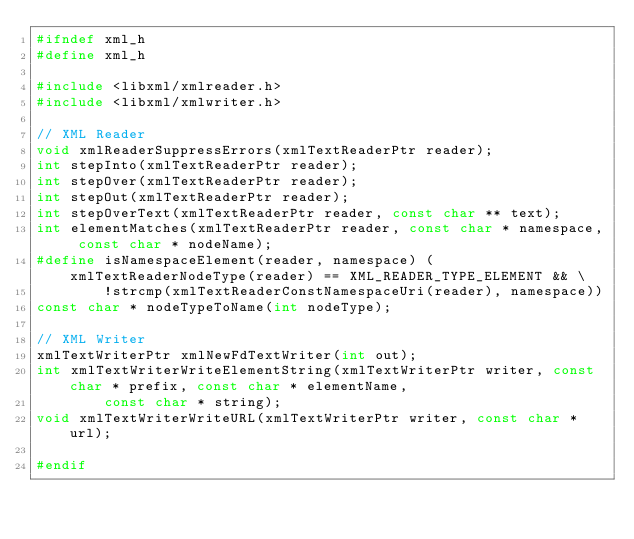<code> <loc_0><loc_0><loc_500><loc_500><_C_>#ifndef xml_h
#define xml_h

#include <libxml/xmlreader.h>
#include <libxml/xmlwriter.h>

// XML Reader
void xmlReaderSuppressErrors(xmlTextReaderPtr reader);
int stepInto(xmlTextReaderPtr reader);
int stepOver(xmlTextReaderPtr reader);
int stepOut(xmlTextReaderPtr reader);
int stepOverText(xmlTextReaderPtr reader, const char ** text);
int elementMatches(xmlTextReaderPtr reader, const char * namespace, const char * nodeName);
#define isNamespaceElement(reader, namespace) (xmlTextReaderNodeType(reader) == XML_READER_TYPE_ELEMENT && \
		!strcmp(xmlTextReaderConstNamespaceUri(reader), namespace))
const char * nodeTypeToName(int nodeType);

// XML Writer
xmlTextWriterPtr xmlNewFdTextWriter(int out);
int xmlTextWriterWriteElementString(xmlTextWriterPtr writer, const char * prefix, const char * elementName,
		const char * string);
void xmlTextWriterWriteURL(xmlTextWriterPtr writer, const char * url);

#endif
</code> 